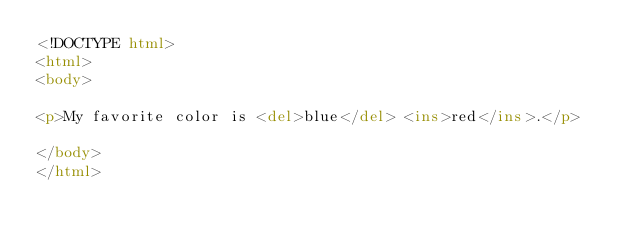Convert code to text. <code><loc_0><loc_0><loc_500><loc_500><_HTML_><!DOCTYPE html>
<html>
<body>

<p>My favorite color is <del>blue</del> <ins>red</ins>.</p>

</body>
</html>
</code> 